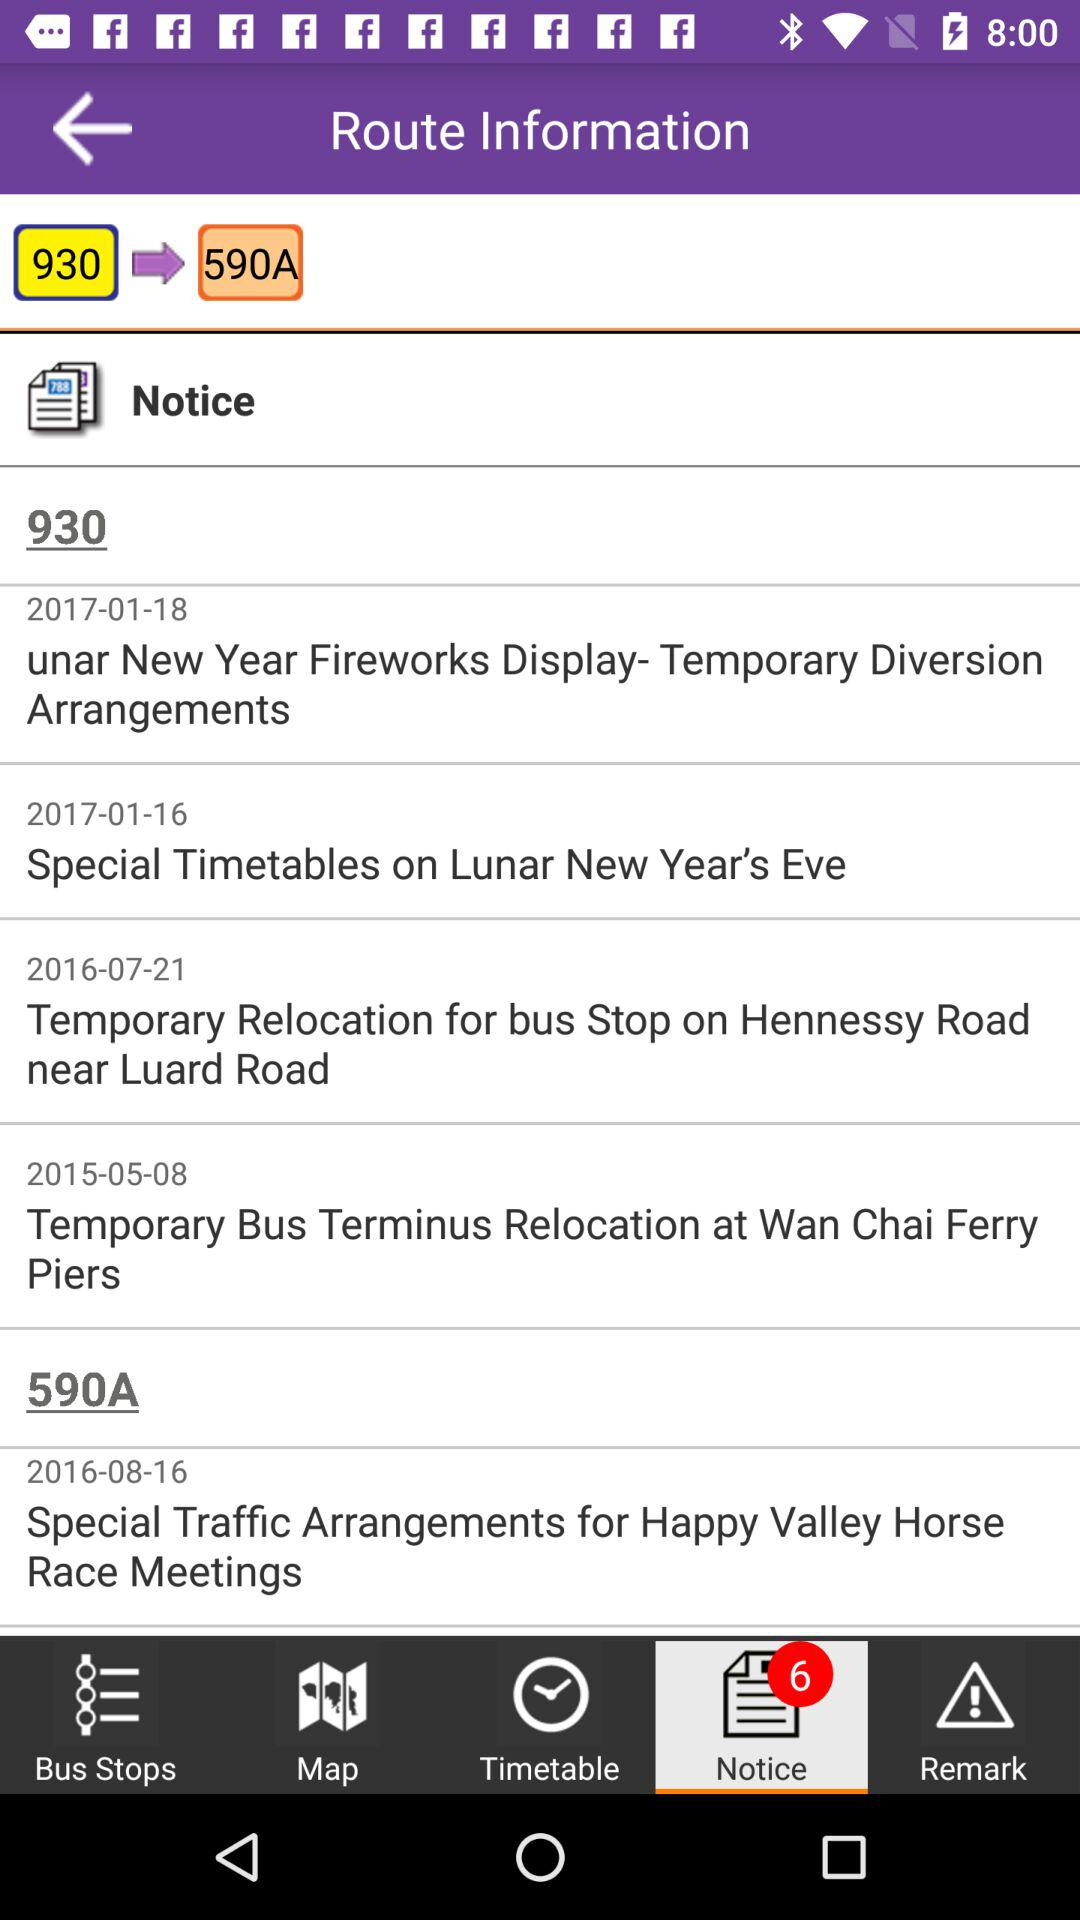How many notifications are on the "Notice" option? There are 6 notifications. 